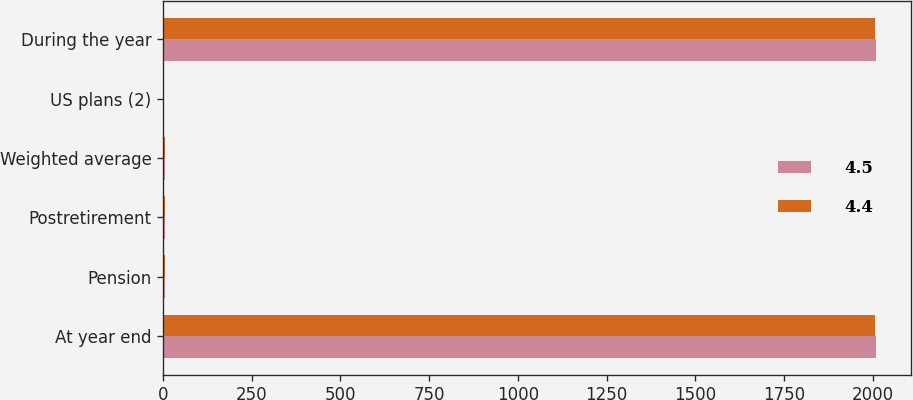Convert chart to OTSL. <chart><loc_0><loc_0><loc_500><loc_500><stacked_bar_chart><ecel><fcel>At year end<fcel>Pension<fcel>Postretirement<fcel>Weighted average<fcel>US plans (2)<fcel>During the year<nl><fcel>4.5<fcel>2009<fcel>5.9<fcel>5.55<fcel>6.5<fcel>3<fcel>2009<nl><fcel>4.4<fcel>2008<fcel>6.1<fcel>6<fcel>6.6<fcel>3<fcel>2008<nl></chart> 